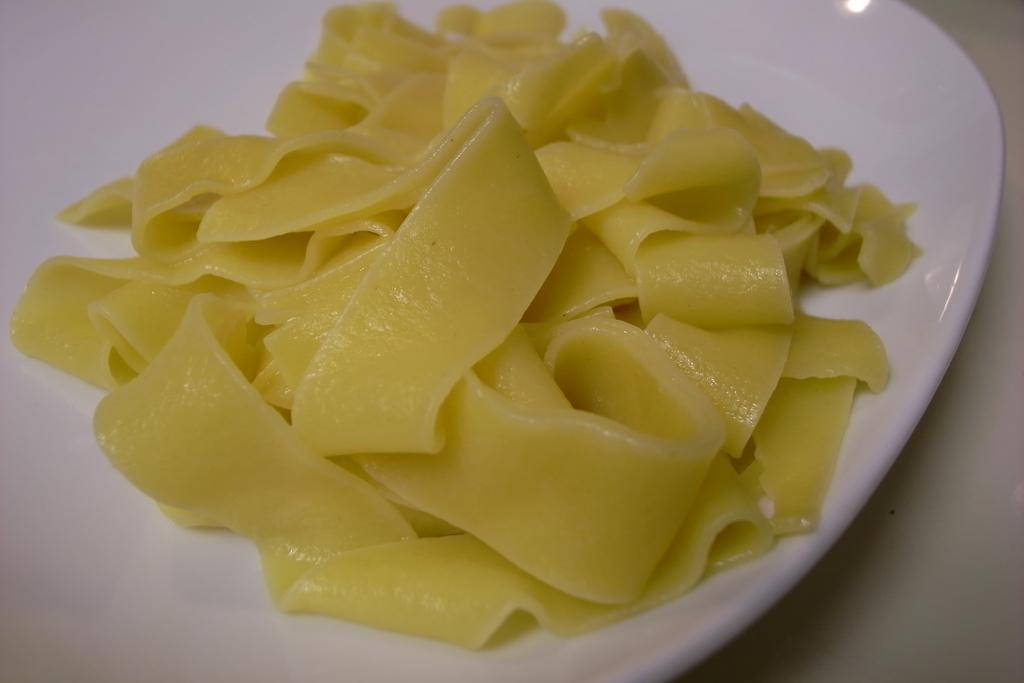What is present in the image related to food? There is food in the image. What is used to serve the food in the image? There is a plate in the image. Where is the food and plate located in the image? The food and plate are on a platform. Who is the creator of the food in the image? There is no information about the creator of the food in the image. Can you describe how the plate turns in the image? The plate does not turn in the image; it remains stationary. 